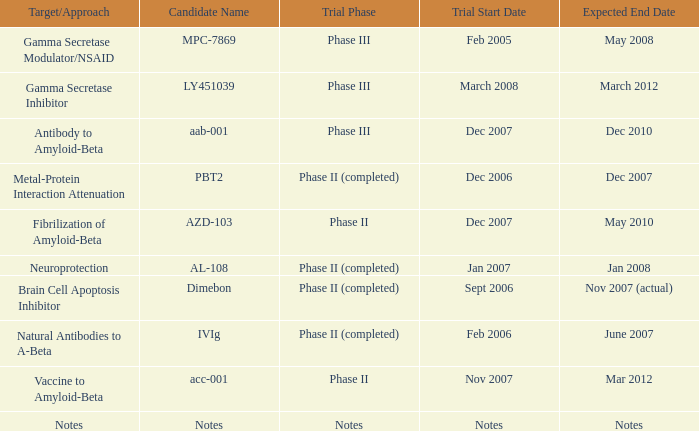When the target/strategy is notes, what is the projected end date? Notes. 